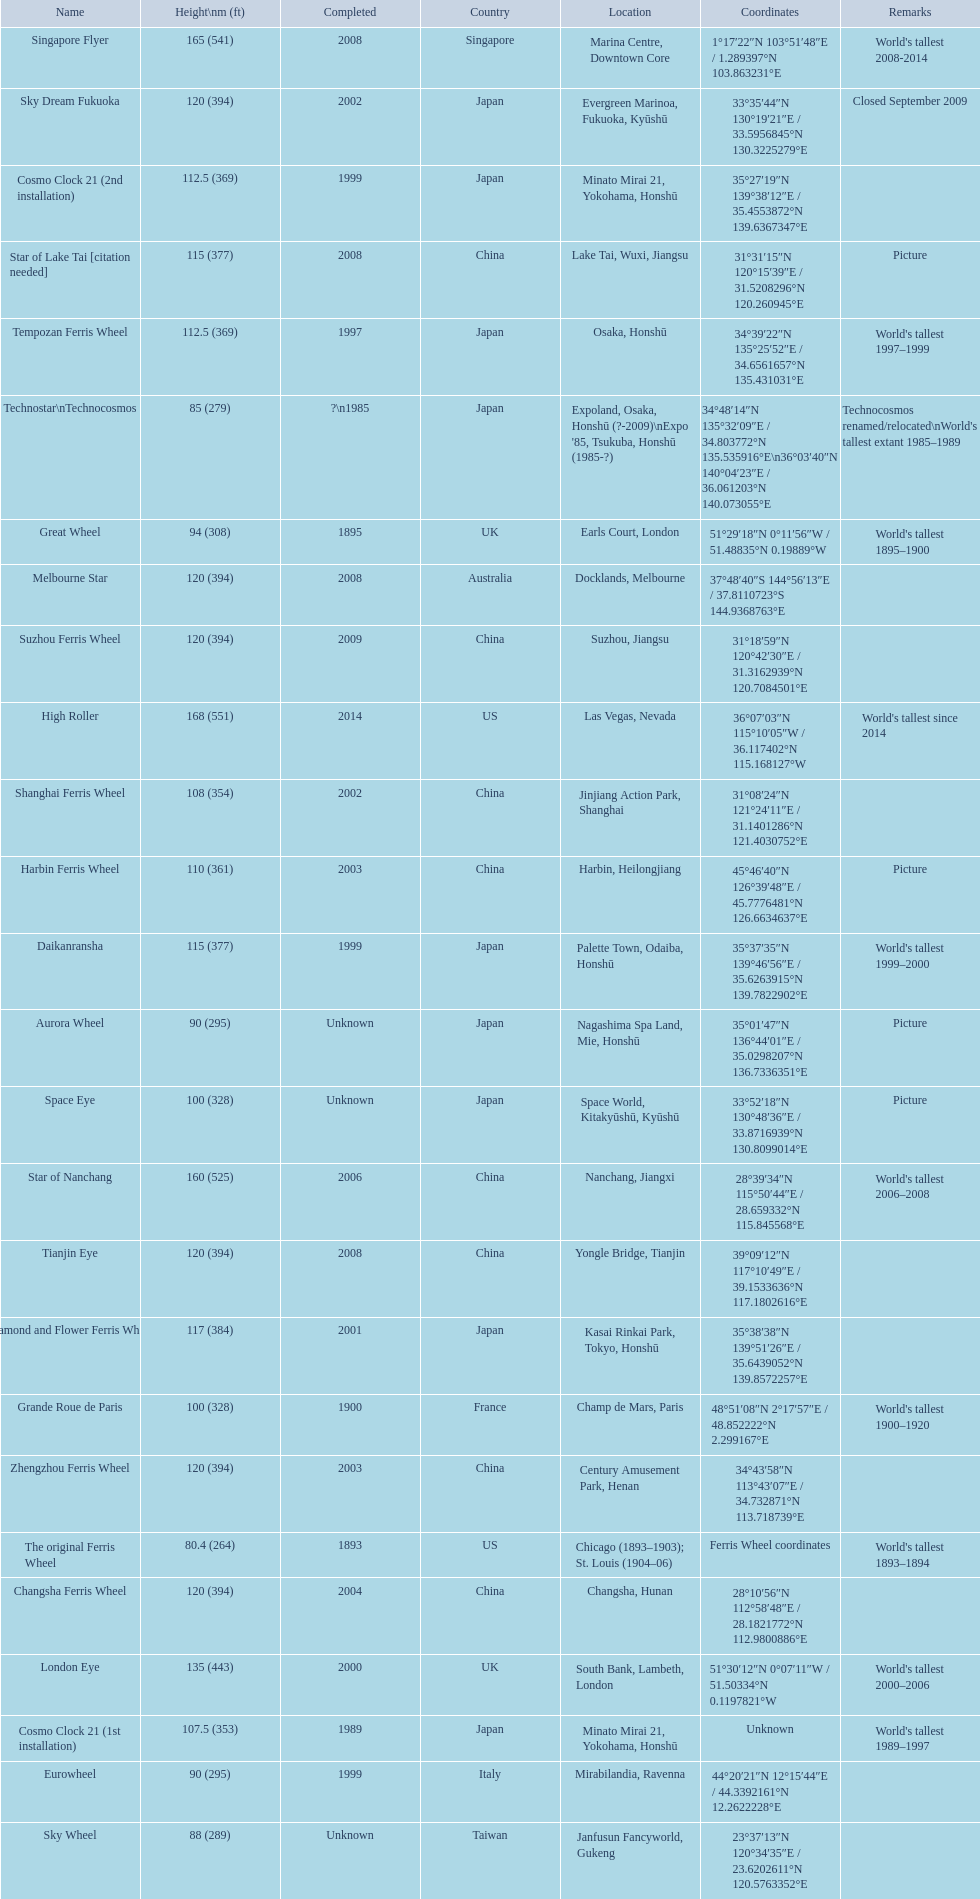What are the different completion dates for the ferris wheel list? 2014, 2008, 2006, 2000, 2009, 2008, 2008, 2004, 2003, 2002, 2001, 2008, 1999, 1999, 1997, 2003, 2002, 1989, Unknown, 1900, 1895, Unknown, 1999, Unknown, ?\n1985, 1893. Which dates for the star of lake tai, star of nanchang, melbourne star? 2006, 2008, 2008. Which is the oldest? 2006. What ride name is this for? Star of Nanchang. 